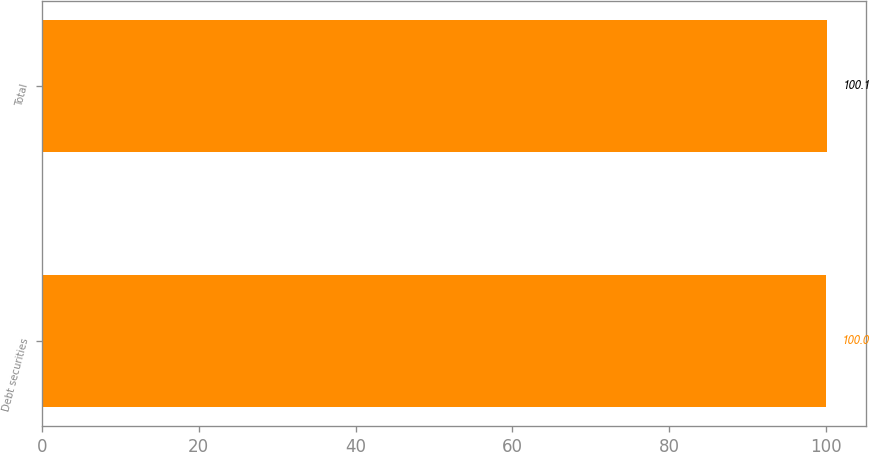Convert chart. <chart><loc_0><loc_0><loc_500><loc_500><bar_chart><fcel>Debt securities<fcel>Total<nl><fcel>100<fcel>100.1<nl></chart> 